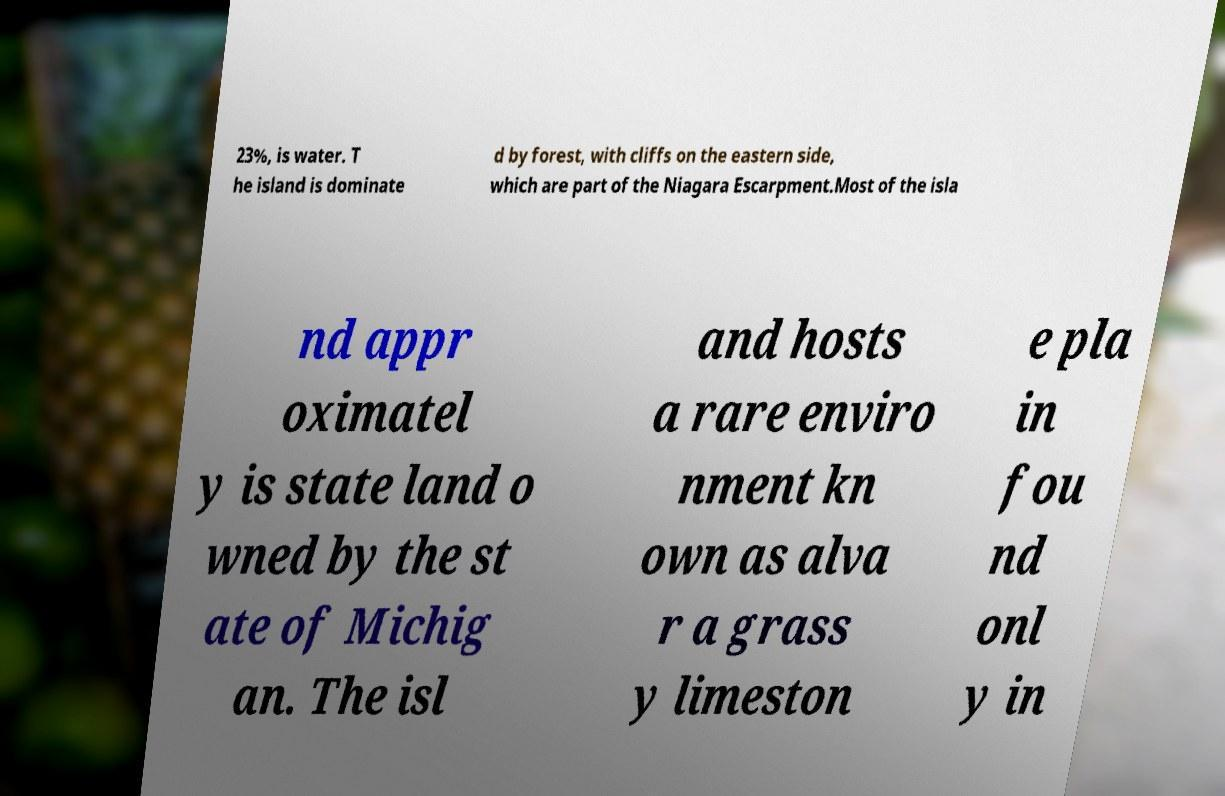Can you accurately transcribe the text from the provided image for me? 23%, is water. T he island is dominate d by forest, with cliffs on the eastern side, which are part of the Niagara Escarpment.Most of the isla nd appr oximatel y is state land o wned by the st ate of Michig an. The isl and hosts a rare enviro nment kn own as alva r a grass y limeston e pla in fou nd onl y in 